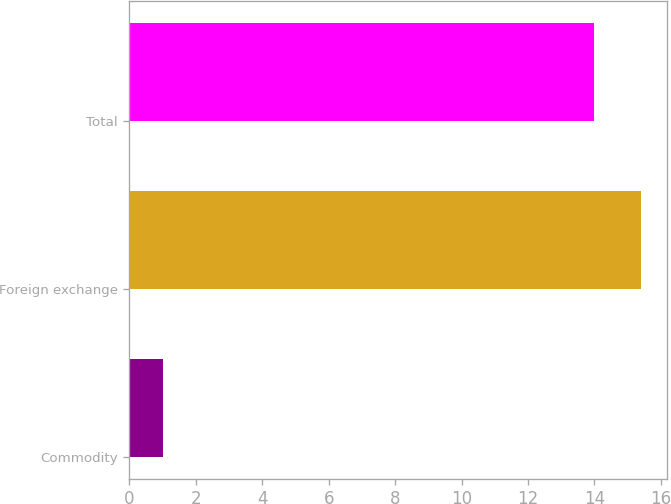Convert chart. <chart><loc_0><loc_0><loc_500><loc_500><bar_chart><fcel>Commodity<fcel>Foreign exchange<fcel>Total<nl><fcel>1<fcel>15.4<fcel>14<nl></chart> 